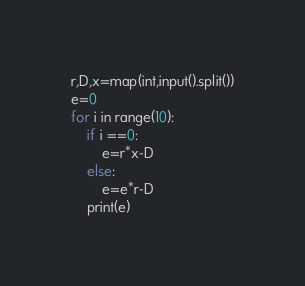<code> <loc_0><loc_0><loc_500><loc_500><_Python_>r,D,x=map(int,input().split())
e=0
for i in range(10):
    if i ==0:
        e=r*x-D
    else:
        e=e*r-D
    print(e)</code> 